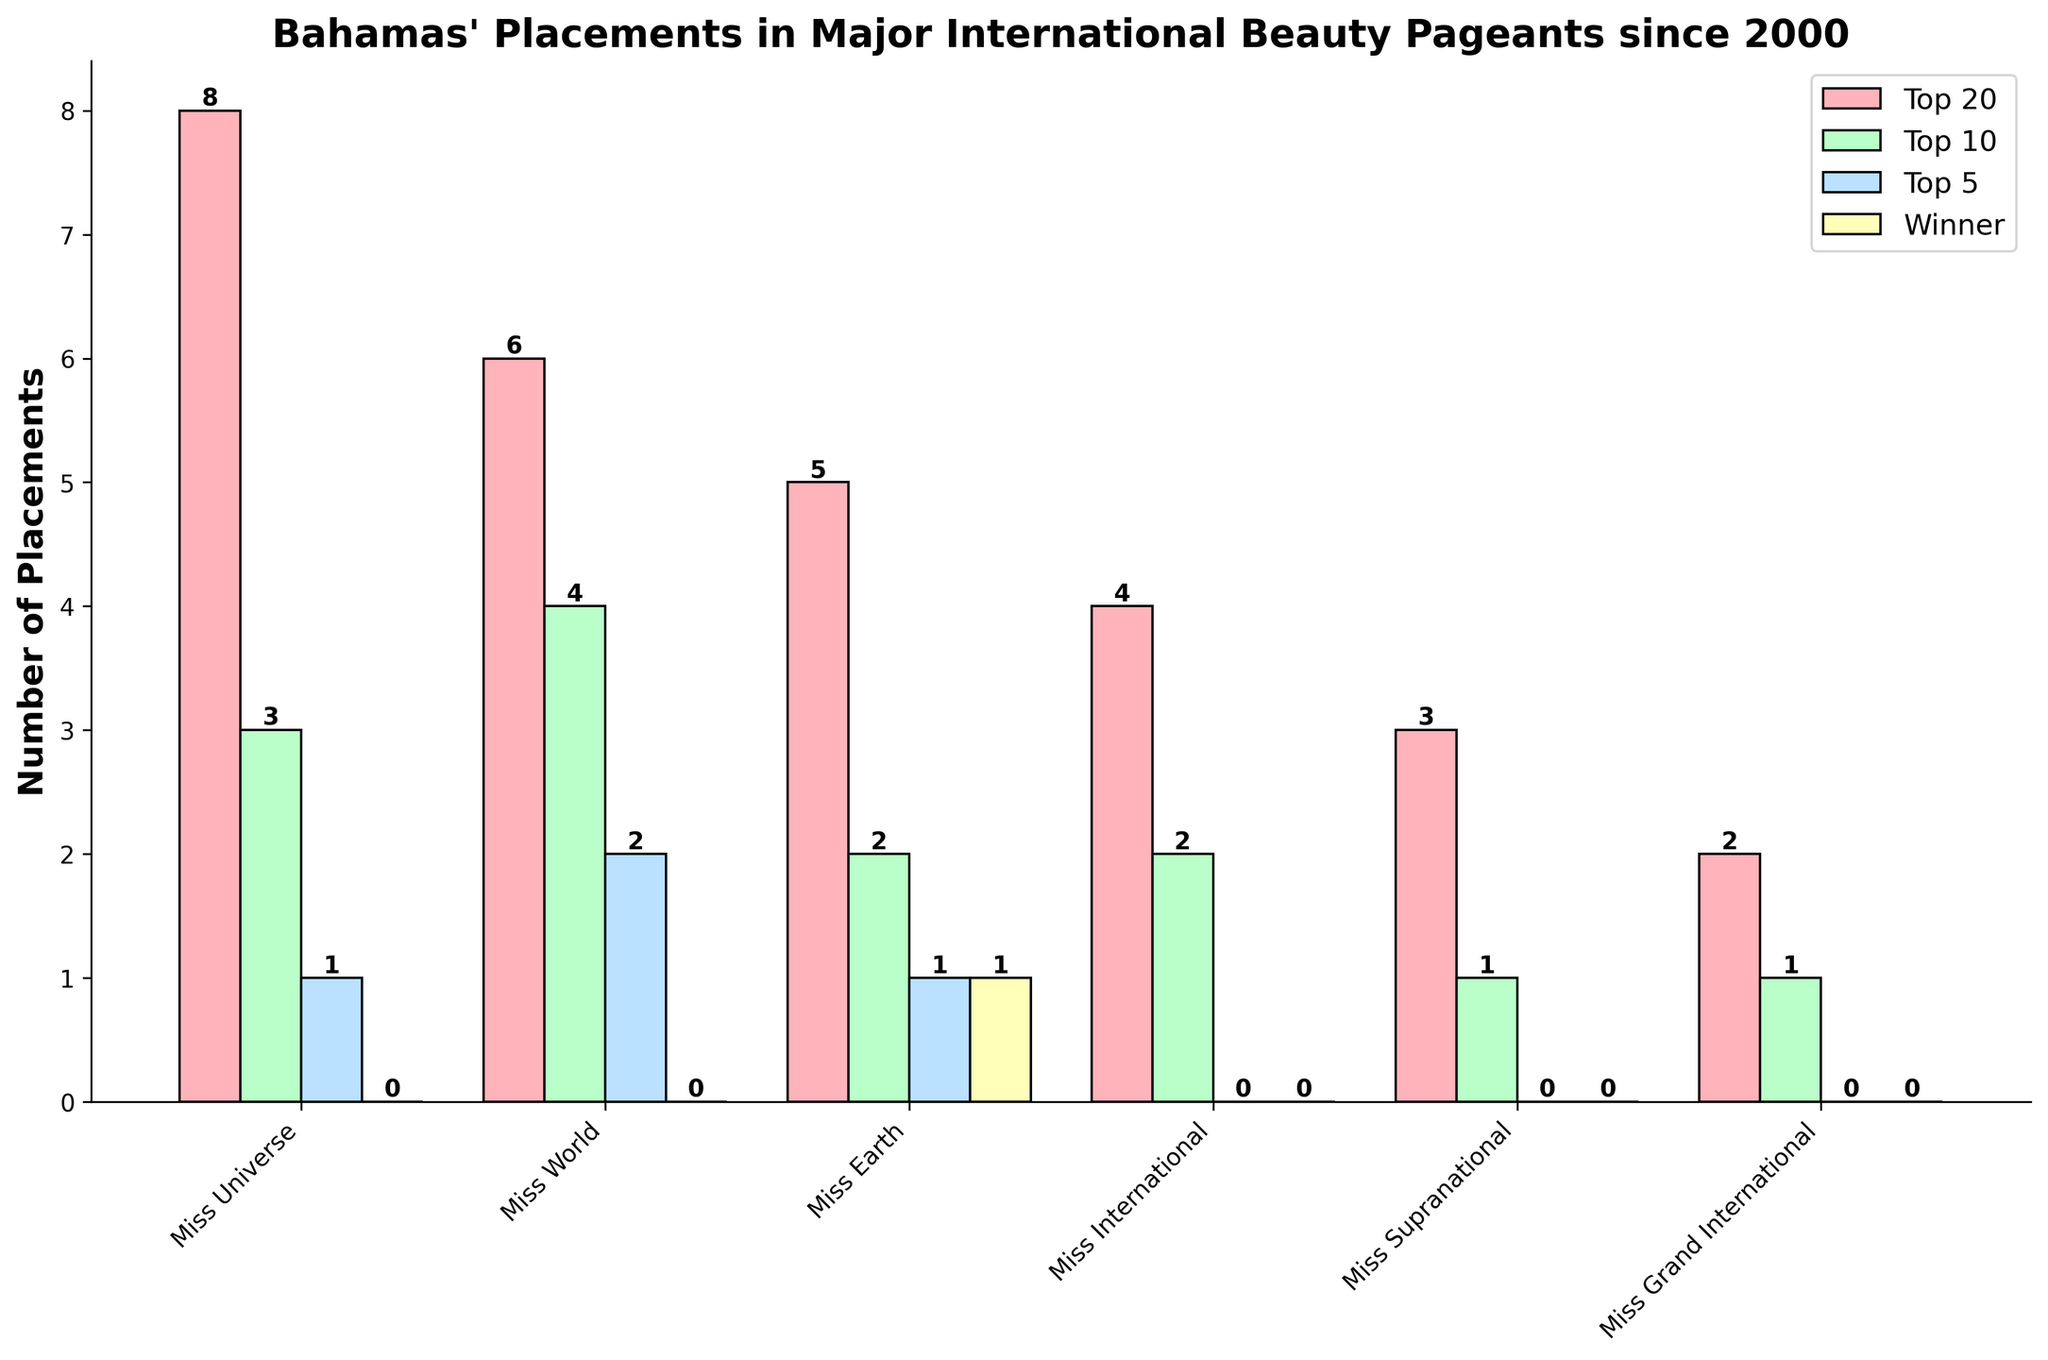Which pageant has the highest number of Top 20 placements? Count the placements for the Top 20 category across all pageants, and the highest value is for Miss Universe with 8 placements.
Answer: Miss Universe Which pageant does Bahamas have its only winner? Observe the "Winner" bars, and Miss Earth is the only pageant where the Bahamas has a winner with 1 placement.
Answer: Miss Earth How many times has the Bahamas placed in the Top 5 across all pageants combined? Sum the Top 5 placements for all pageants: 1 (Miss Universe) + 2 (Miss World) + 1 (Miss Earth) + 0 (Miss International) + 0 (Miss Supranational) + 0 (Miss Grand International) = 4 placements.
Answer: 4 Which pageant has the least number of overall placements across all categories? Sum all categories for each pageant; the smallest total is for Miss Grand International with 2 (Top 20) + 1 (Top 10) + 0 (Top 5) + 0 (Winner) = 3 placements.
Answer: Miss Grand International How many more Top 20 placements does Miss Universe have compared to Miss Grand International? Subtract the Top 20 placements of Miss Grand International (2) from Miss Universe (8): 8 - 2 = 6.
Answer: 6 Which two pageants have the same number of Top 5 placements, and what is that number? Compare Top 5 placements and find that Miss Universe, Miss Earth both have 1 Top 5 placement.
Answer: Miss Universe, Miss Earth; 1 How many total placements does Miss World have in the Top 10 category? The Top 10 placements for Miss World are presented as 4.
Answer: 4 Which category has the highest variation in the number of placements across all pageants? Observe all categories: Top 20 (ranging from 2 to 8), Top 10 (ranging from 1 to 4), Top 5 (ranging from 0 to 2), Winner (0 to 1). Highest variation is in Top 20 category.
Answer: Top 20 What is the total number of all placements for Miss International across all categories? Sum the placements for Miss International: 4 (Top 20) + 2 (Top 10) + 0 (Top 5) + 0 (Winner) = 6 placements.
Answer: 6 